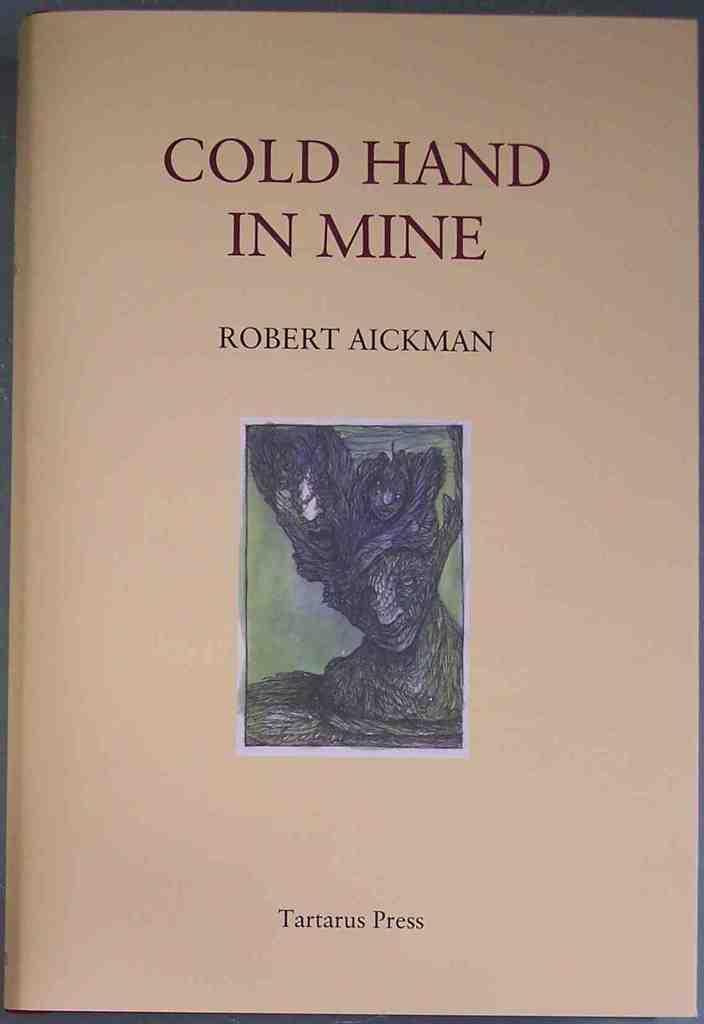Who wrote the book?
Offer a very short reply. Robert aickman. 